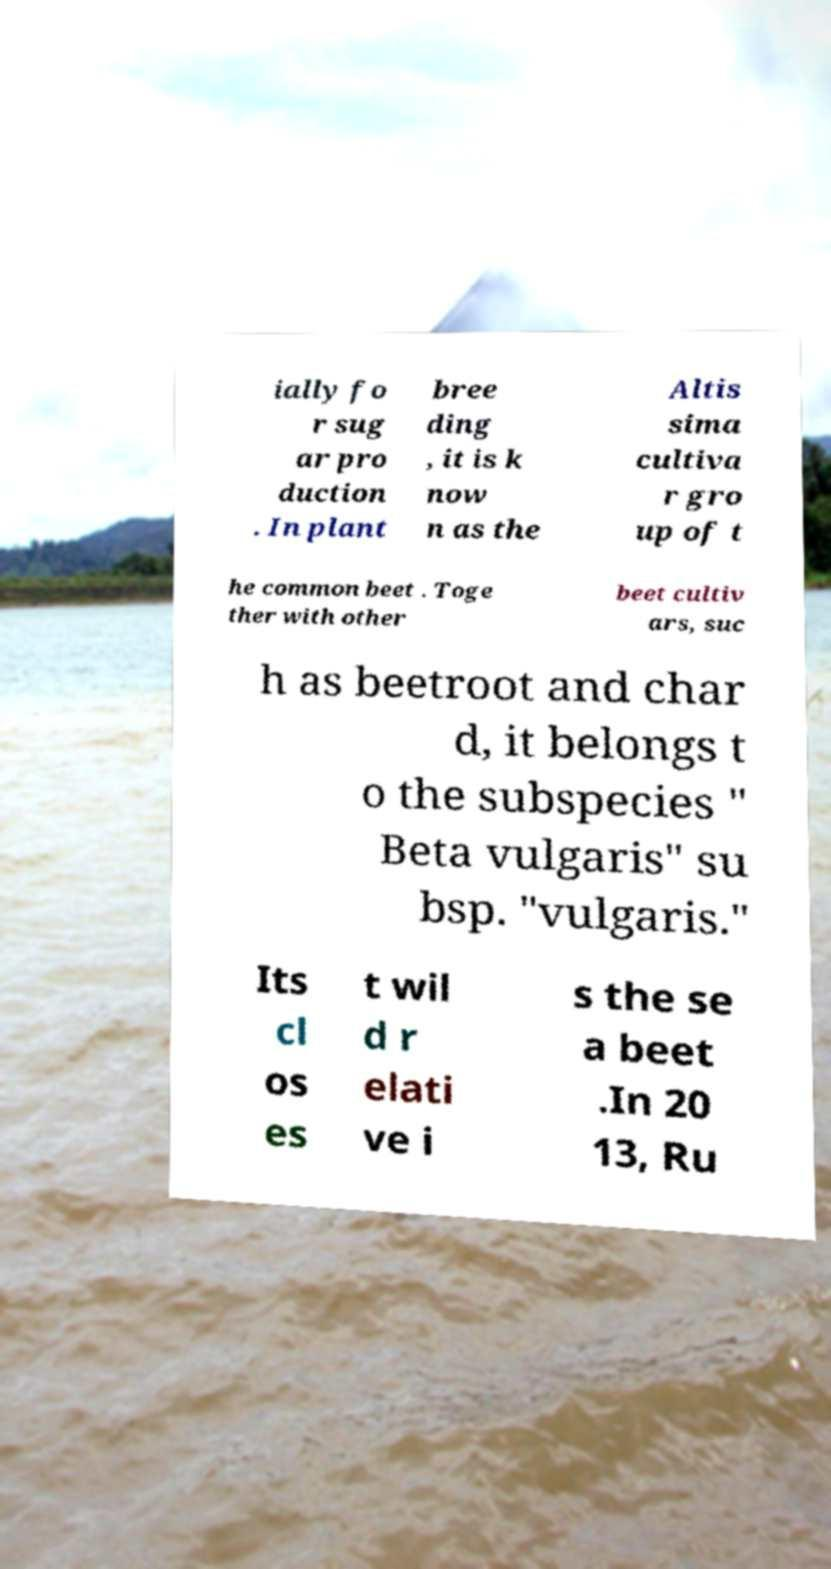Could you assist in decoding the text presented in this image and type it out clearly? ially fo r sug ar pro duction . In plant bree ding , it is k now n as the Altis sima cultiva r gro up of t he common beet . Toge ther with other beet cultiv ars, suc h as beetroot and char d, it belongs t o the subspecies " Beta vulgaris" su bsp. "vulgaris." Its cl os es t wil d r elati ve i s the se a beet .In 20 13, Ru 